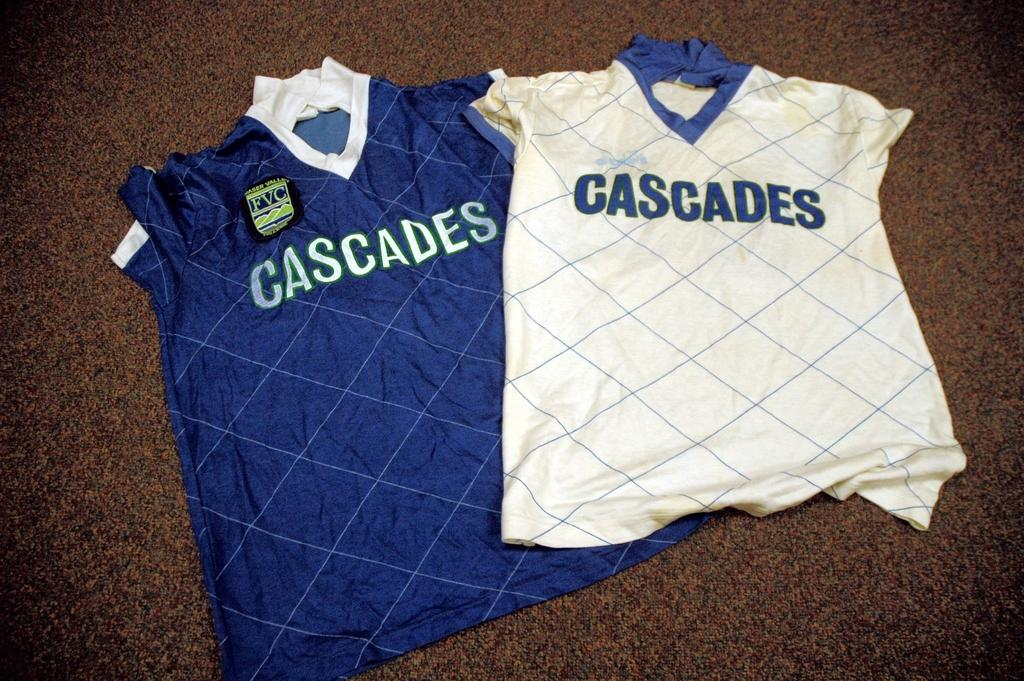<image>
Relay a brief, clear account of the picture shown. Two jerseys both have the word Cascades on the front. 